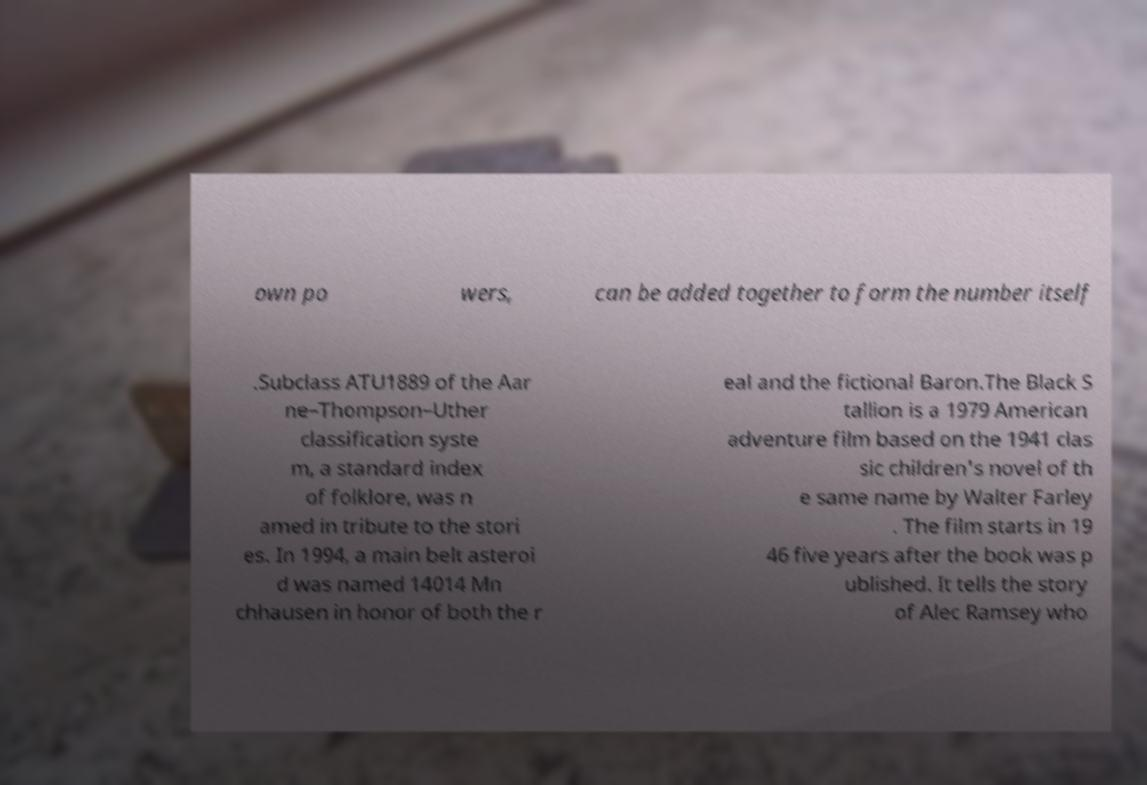Could you assist in decoding the text presented in this image and type it out clearly? own po wers, can be added together to form the number itself .Subclass ATU1889 of the Aar ne–Thompson–Uther classification syste m, a standard index of folklore, was n amed in tribute to the stori es. In 1994, a main belt asteroi d was named 14014 Mn chhausen in honor of both the r eal and the fictional Baron.The Black S tallion is a 1979 American adventure film based on the 1941 clas sic children's novel of th e same name by Walter Farley . The film starts in 19 46 five years after the book was p ublished. It tells the story of Alec Ramsey who 